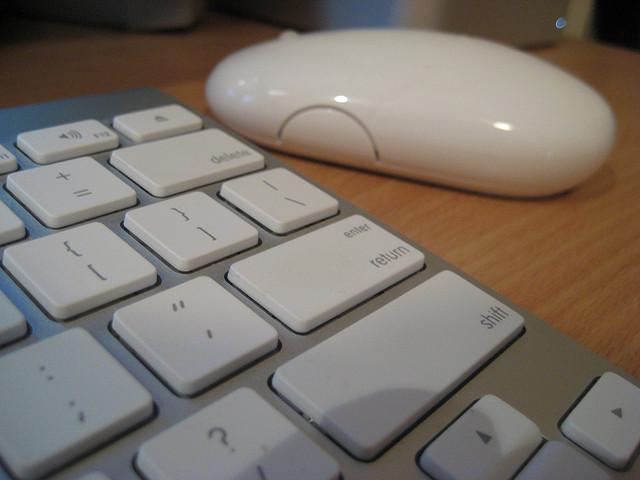What color is the mouse?
Be succinct. White. Is the mouse wired or wireless?
Give a very brief answer. Wireless. How many keys are showing?
Keep it brief. 19. 